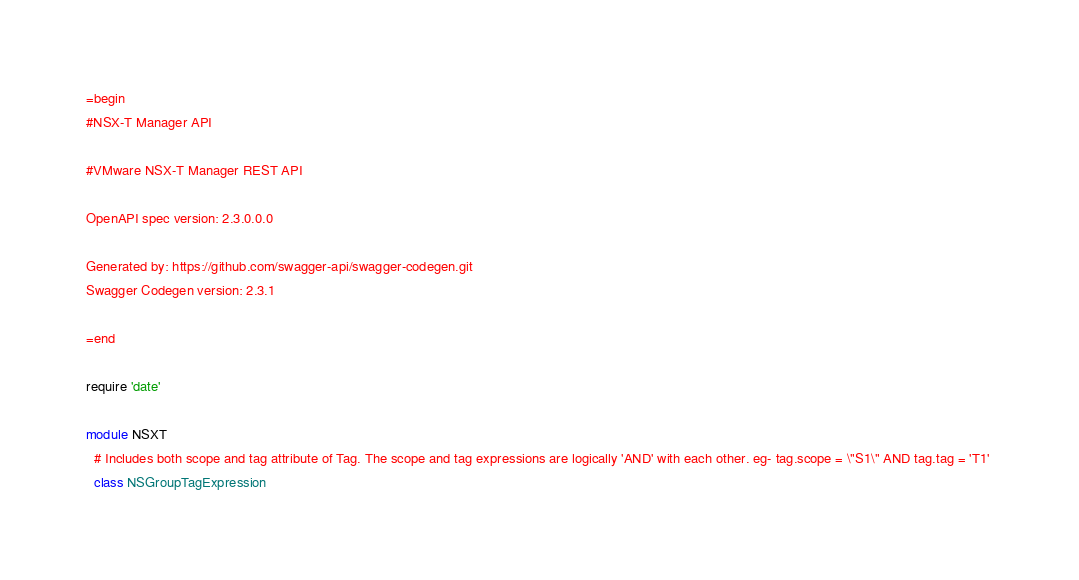<code> <loc_0><loc_0><loc_500><loc_500><_Ruby_>=begin
#NSX-T Manager API

#VMware NSX-T Manager REST API

OpenAPI spec version: 2.3.0.0.0

Generated by: https://github.com/swagger-api/swagger-codegen.git
Swagger Codegen version: 2.3.1

=end

require 'date'

module NSXT
  # Includes both scope and tag attribute of Tag. The scope and tag expressions are logically 'AND' with each other. eg- tag.scope = \"S1\" AND tag.tag = 'T1' 
  class NSGroupTagExpression</code> 